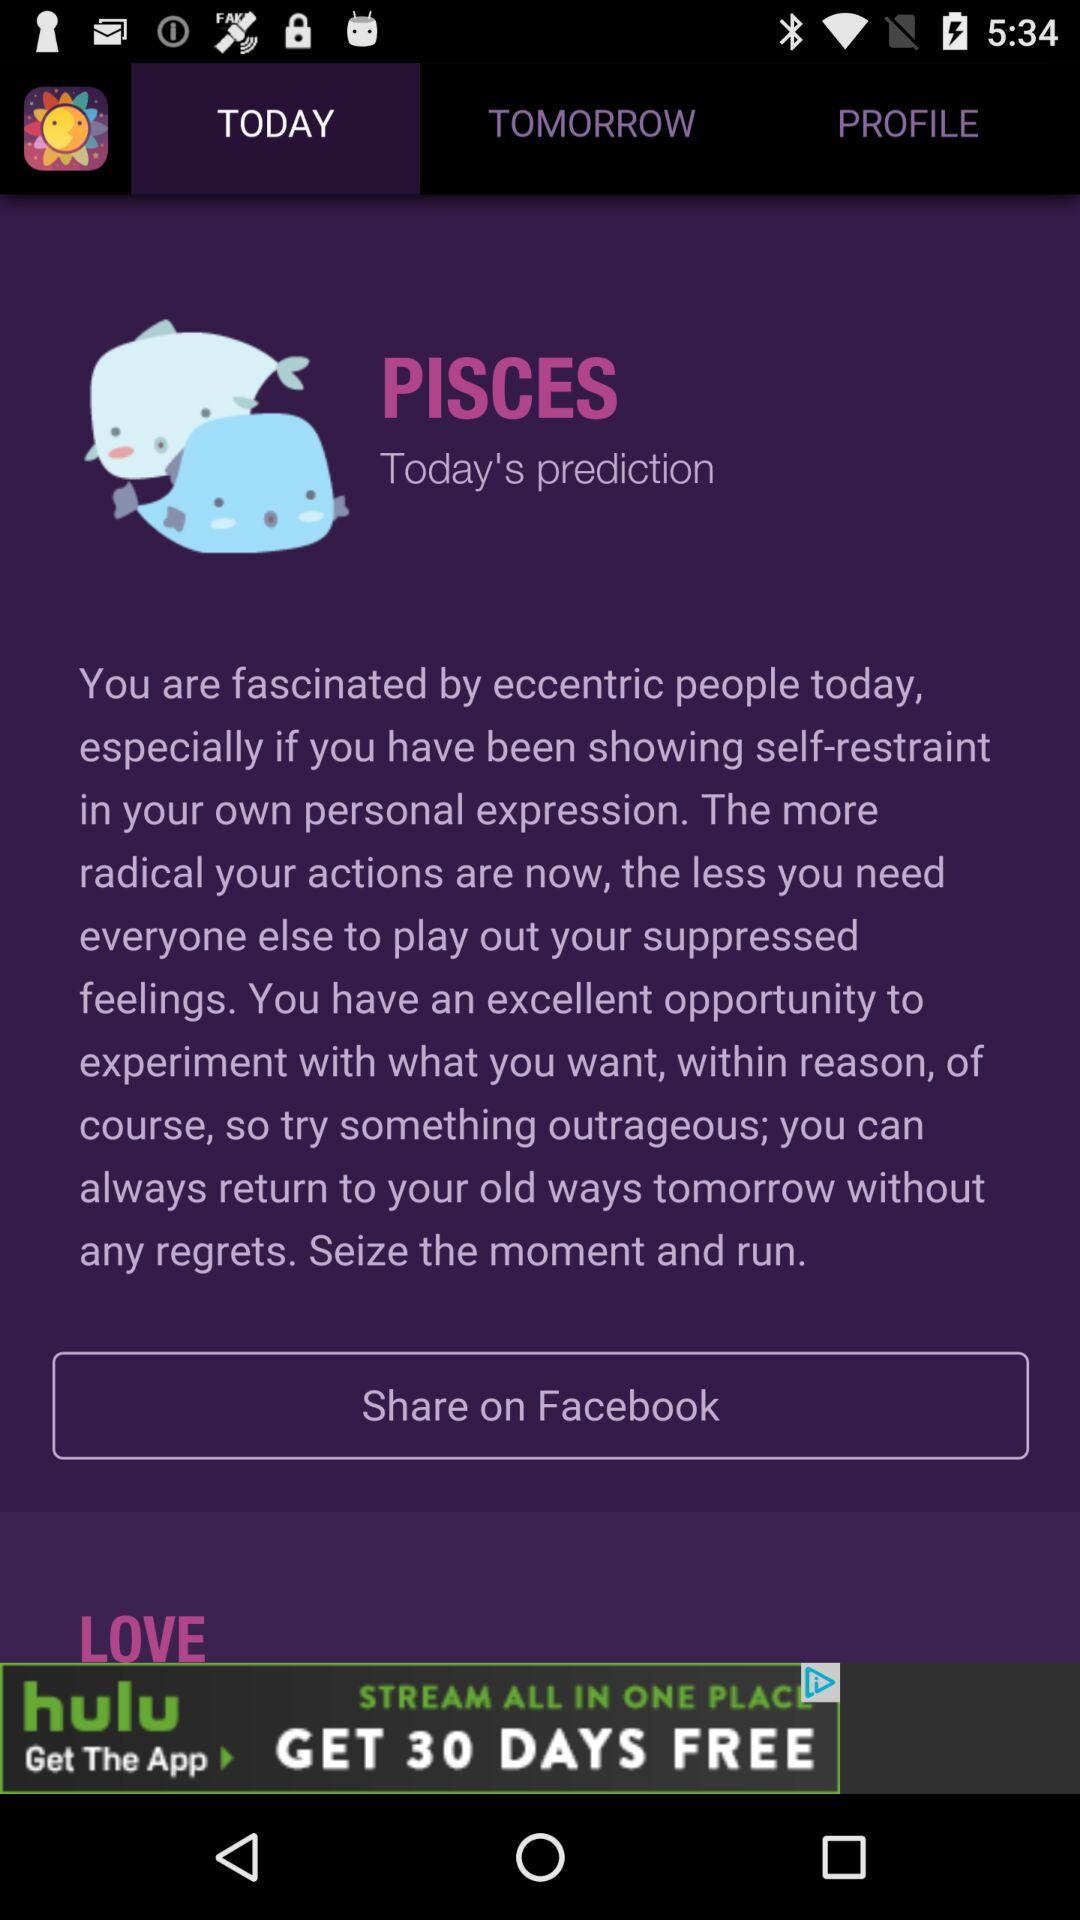Which tab am I on? You are on the "TODAY" tab. 